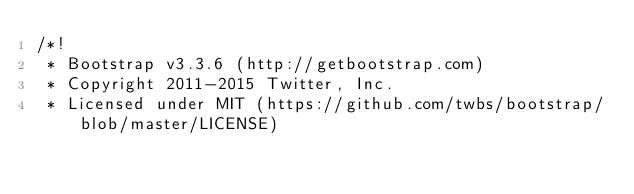<code> <loc_0><loc_0><loc_500><loc_500><_CSS_>/*!
 * Bootstrap v3.3.6 (http://getbootstrap.com)
 * Copyright 2011-2015 Twitter, Inc.
 * Licensed under MIT (https://github.com/twbs/bootstrap/blob/master/LICENSE)</code> 